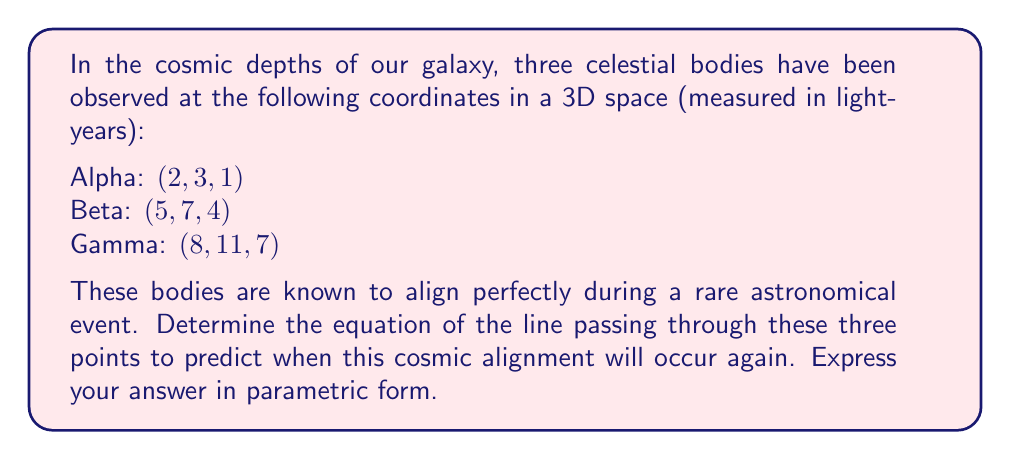Can you answer this question? Let's approach this cosmic conundrum step by step, detective:

1) First, we need to verify that these three points indeed lie on a straight line. We can do this by showing that the vector from Alpha to Beta is parallel to the vector from Alpha to Gamma.

   Vector Alpha to Beta: $\vec{AB} = (5-2, 7-3, 4-1) = (3, 4, 3)$
   Vector Alpha to Gamma: $\vec{AG} = (8-2, 11-3, 7-1) = (6, 8, 6)$

   We can see that $\vec{AG} = 2\vec{AB}$, confirming that the points are collinear.

2) Now that we've confirmed the alignment, let's find the parametric equation of the line. We'll use Alpha as our reference point and $\vec{AB}$ as our direction vector.

3) The parametric form of a line is given by:

   $$(x, y, z) = (x_0, y_0, z_0) + t(a, b, c)$$

   Where $(x_0, y_0, z_0)$ is a point on the line (we'll use Alpha), and $(a, b, c)$ is a direction vector (we'll use $\vec{AB}$).

4) Substituting our values:

   $$(x, y, z) = (2, 3, 1) + t(3, 4, 3)$$

5) We can write this as separate equations for x, y, and z:

   $$x = 2 + 3t$$
   $$y = 3 + 4t$$
   $$z = 1 + 3t$$

This parametric equation represents the line of alignment for these celestial bodies.
Answer: The parametric equation of the line is:

$$x = 2 + 3t$$
$$y = 3 + 4t$$
$$z = 1 + 3t$$

Where $t$ is a real number parameter. 